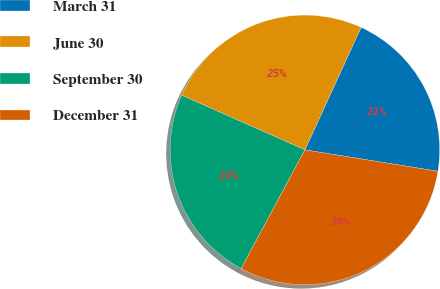Convert chart to OTSL. <chart><loc_0><loc_0><loc_500><loc_500><pie_chart><fcel>March 31<fcel>June 30<fcel>September 30<fcel>December 31<nl><fcel>20.7%<fcel>25.2%<fcel>23.8%<fcel>30.3%<nl></chart> 